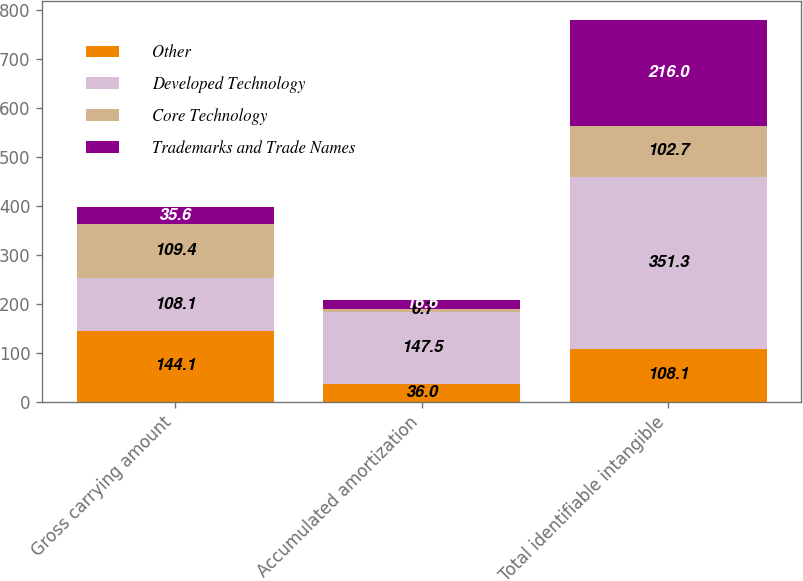Convert chart. <chart><loc_0><loc_0><loc_500><loc_500><stacked_bar_chart><ecel><fcel>Gross carrying amount<fcel>Accumulated amortization<fcel>Total identifiable intangible<nl><fcel>Other<fcel>144.1<fcel>36<fcel>108.1<nl><fcel>Developed Technology<fcel>108.1<fcel>147.5<fcel>351.3<nl><fcel>Core Technology<fcel>109.4<fcel>6.7<fcel>102.7<nl><fcel>Trademarks and Trade Names<fcel>35.6<fcel>16.6<fcel>216<nl></chart> 